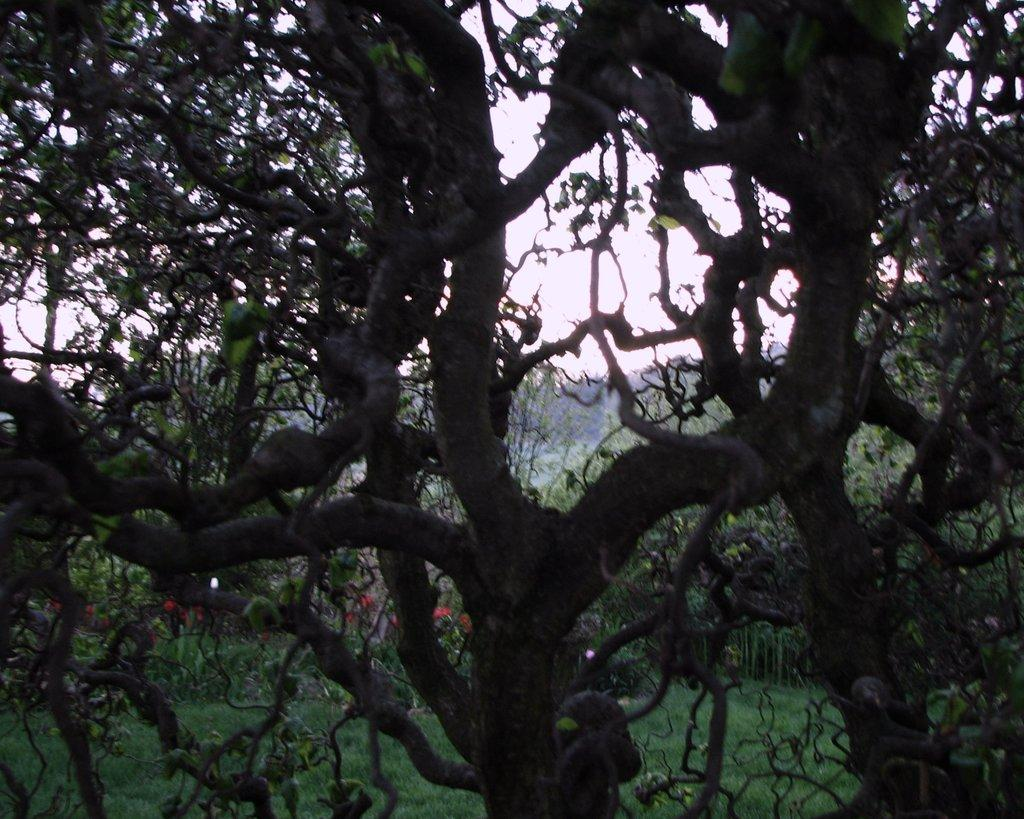What type of vegetation is visible in the image? There is grass in the image. What other natural elements can be seen in the image? There are trees in the image. What part of the natural environment is visible in the background of the image? The sky is visible in the background of the image. Is there any smoke visible in the image? No, there is no smoke present in the image. Can you see anyone blowing bubbles in the image? No, there is no one blowing bubbles in the image. 